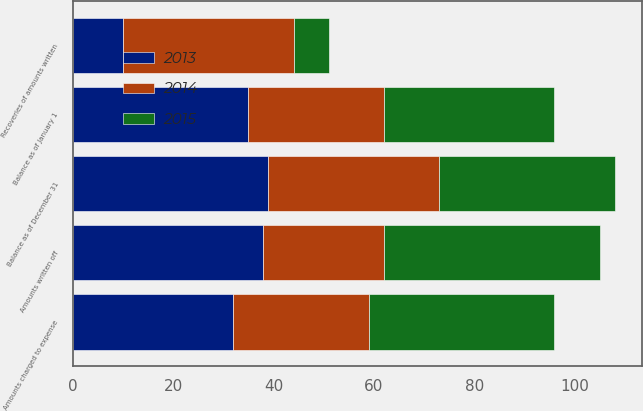Convert chart. <chart><loc_0><loc_0><loc_500><loc_500><stacked_bar_chart><ecel><fcel>Balance as of January 1<fcel>Amounts charged to expense<fcel>Amounts written off<fcel>Recoveries of amounts written<fcel>Balance as of December 31<nl><fcel>2013<fcel>35<fcel>32<fcel>38<fcel>10<fcel>39<nl><fcel>2015<fcel>34<fcel>37<fcel>43<fcel>7<fcel>35<nl><fcel>2014<fcel>27<fcel>27<fcel>24<fcel>34<fcel>34<nl></chart> 